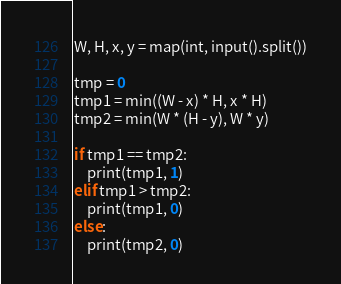<code> <loc_0><loc_0><loc_500><loc_500><_Python_>W, H, x, y = map(int, input().split())

tmp = 0
tmp1 = min((W - x) * H, x * H)
tmp2 = min(W * (H - y), W * y)

if tmp1 == tmp2:
    print(tmp1, 1)
elif tmp1 > tmp2:
    print(tmp1, 0)
else:
    print(tmp2, 0)
</code> 